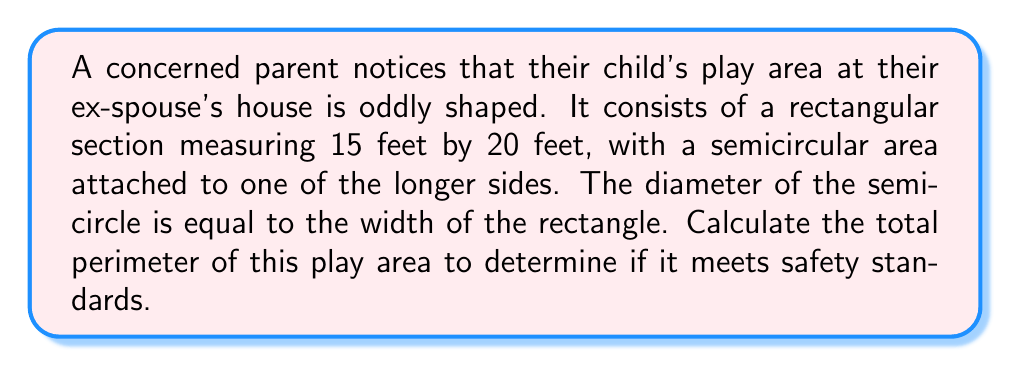Solve this math problem. Let's approach this step-by-step:

1) First, let's identify the components of the play area:
   - A rectangle: 15 feet by 20 feet
   - A semicircle attached to one of the 20-foot sides

2) Calculate the perimeter of the rectangle:
   $$P_{rectangle} = 2(l + w) = 2(20 + 15) = 2(35) = 70\text{ feet}$$

3) The semicircle is attached to one of the 20-foot sides, so we need to subtract this side from our rectangle perimeter:
   $$70 - 20 = 50\text{ feet}$$

4) Now, we need to add the semicircle's arc length. The diameter of the semicircle is equal to the width of the rectangle (15 feet).
   Arc length of a semicircle = $\frac{1}{2} \times \pi \times \text{diameter}$
   $$\text{Arc length} = \frac{1}{2} \times \pi \times 15 \approx 23.56\text{ feet}$$

5) Total perimeter:
   $$\text{Total Perimeter} = 50 + 23.56 = 73.56\text{ feet}$$

[asy]
unitsize(10);
fill((0,0)--(4,0)--(4,3)--(0,3)--cycle,lightgray);
fill(arc((0,1.5),1.5,270,90),lightgray);
draw((0,0)--(4,0)--(4,3)--(0,3)--cycle);
draw(arc((0,1.5),1.5,270,90));
label("20 ft", (2,0), S);
label("15 ft", (4,1.5), E);
[/asy]
Answer: $73.56\text{ feet}$ 